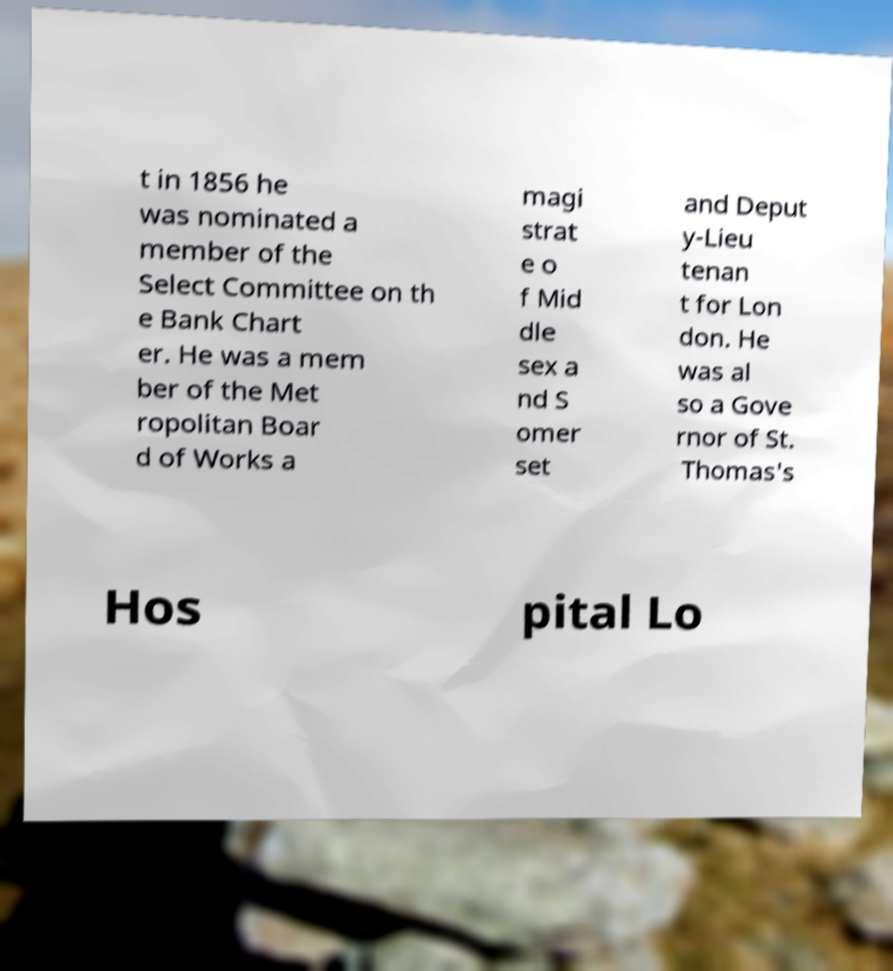Can you accurately transcribe the text from the provided image for me? t in 1856 he was nominated a member of the Select Committee on th e Bank Chart er. He was a mem ber of the Met ropolitan Boar d of Works a magi strat e o f Mid dle sex a nd S omer set and Deput y-Lieu tenan t for Lon don. He was al so a Gove rnor of St. Thomas's Hos pital Lo 